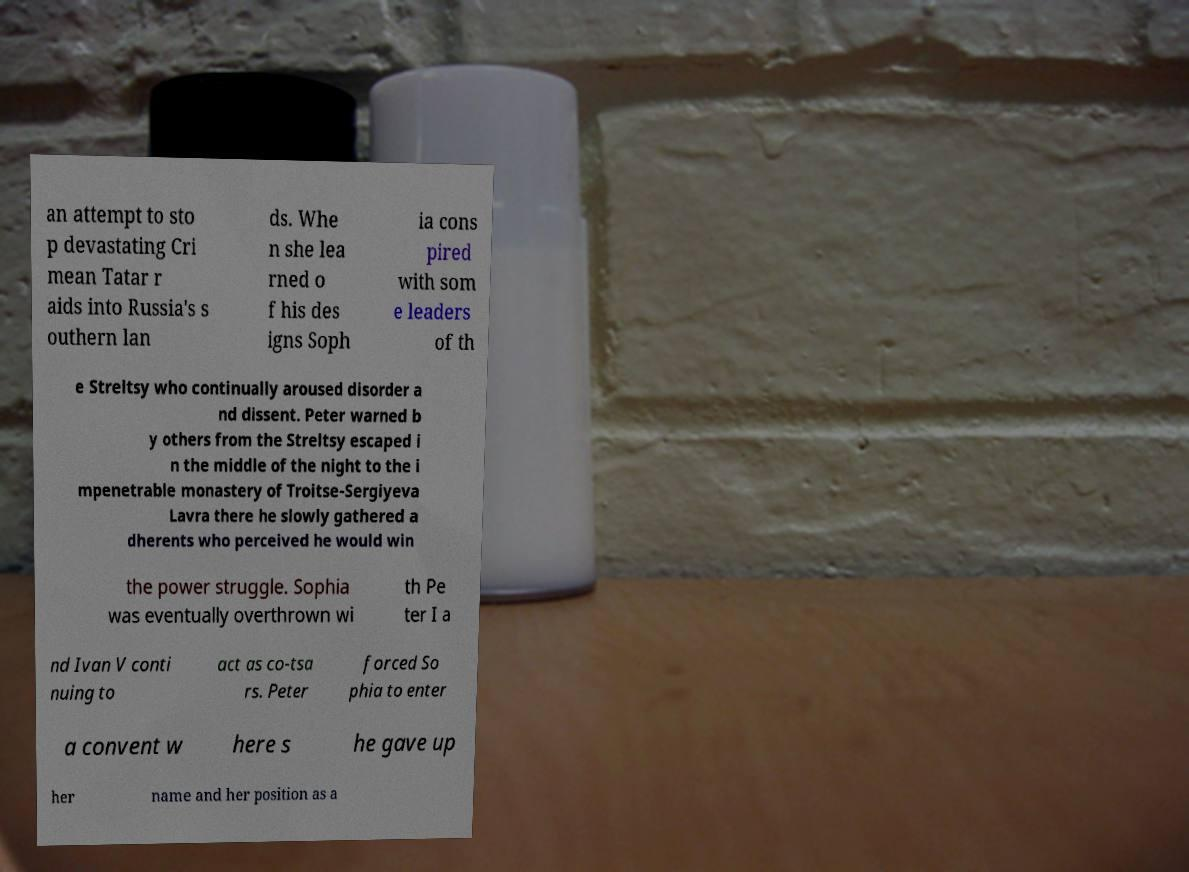There's text embedded in this image that I need extracted. Can you transcribe it verbatim? an attempt to sto p devastating Cri mean Tatar r aids into Russia's s outhern lan ds. Whe n she lea rned o f his des igns Soph ia cons pired with som e leaders of th e Streltsy who continually aroused disorder a nd dissent. Peter warned b y others from the Streltsy escaped i n the middle of the night to the i mpenetrable monastery of Troitse-Sergiyeva Lavra there he slowly gathered a dherents who perceived he would win the power struggle. Sophia was eventually overthrown wi th Pe ter I a nd Ivan V conti nuing to act as co-tsa rs. Peter forced So phia to enter a convent w here s he gave up her name and her position as a 